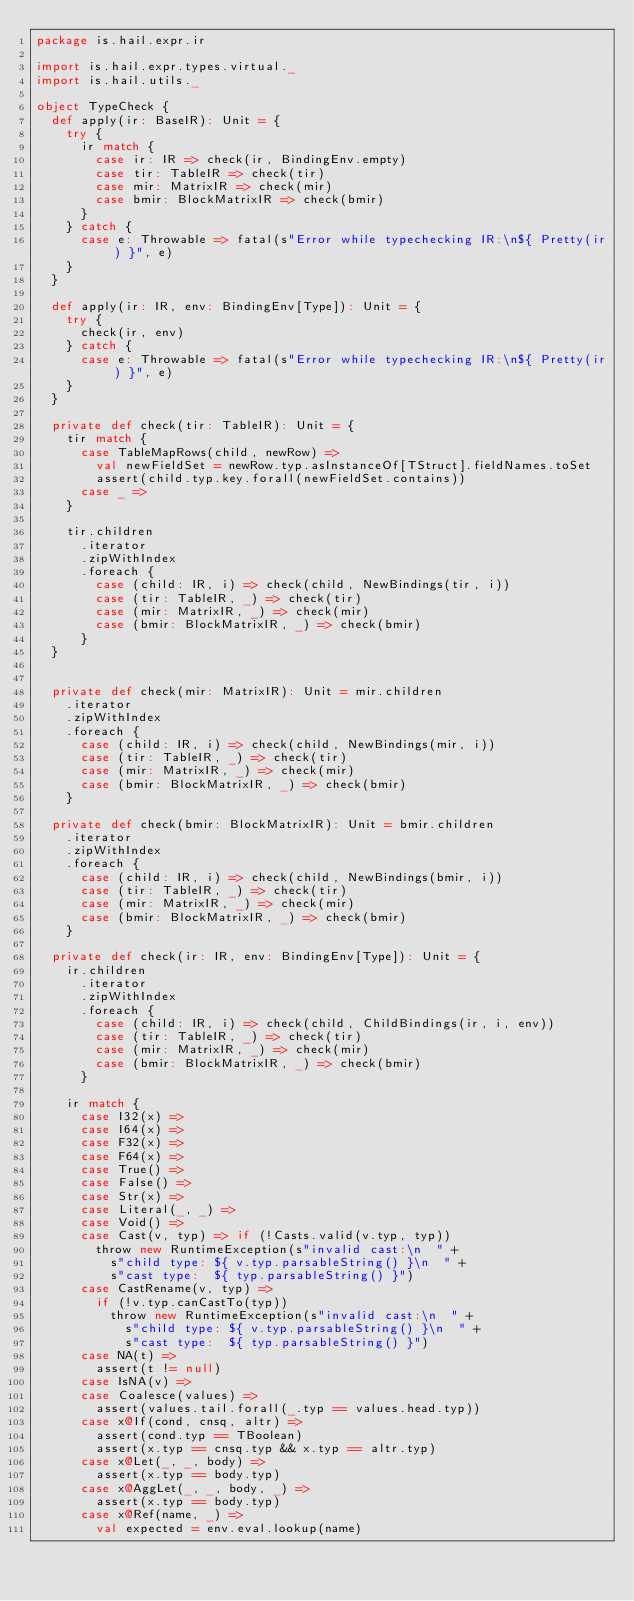<code> <loc_0><loc_0><loc_500><loc_500><_Scala_>package is.hail.expr.ir

import is.hail.expr.types.virtual._
import is.hail.utils._

object TypeCheck {
  def apply(ir: BaseIR): Unit = {
    try {
      ir match {
        case ir: IR => check(ir, BindingEnv.empty)
        case tir: TableIR => check(tir)
        case mir: MatrixIR => check(mir)
        case bmir: BlockMatrixIR => check(bmir)
      }
    } catch {
      case e: Throwable => fatal(s"Error while typechecking IR:\n${ Pretty(ir) }", e)
    }
  }

  def apply(ir: IR, env: BindingEnv[Type]): Unit = {
    try {
      check(ir, env)
    } catch {
      case e: Throwable => fatal(s"Error while typechecking IR:\n${ Pretty(ir) }", e)
    }
  }

  private def check(tir: TableIR): Unit = {
    tir match {
      case TableMapRows(child, newRow) =>
        val newFieldSet = newRow.typ.asInstanceOf[TStruct].fieldNames.toSet
        assert(child.typ.key.forall(newFieldSet.contains))
      case _ =>
    }

    tir.children
      .iterator
      .zipWithIndex
      .foreach {
        case (child: IR, i) => check(child, NewBindings(tir, i))
        case (tir: TableIR, _) => check(tir)
        case (mir: MatrixIR, _) => check(mir)
        case (bmir: BlockMatrixIR, _) => check(bmir)
      }
  }


  private def check(mir: MatrixIR): Unit = mir.children
    .iterator
    .zipWithIndex
    .foreach {
      case (child: IR, i) => check(child, NewBindings(mir, i))
      case (tir: TableIR, _) => check(tir)
      case (mir: MatrixIR, _) => check(mir)
      case (bmir: BlockMatrixIR, _) => check(bmir)
    }

  private def check(bmir: BlockMatrixIR): Unit = bmir.children
    .iterator
    .zipWithIndex
    .foreach {
      case (child: IR, i) => check(child, NewBindings(bmir, i))
      case (tir: TableIR, _) => check(tir)
      case (mir: MatrixIR, _) => check(mir)
      case (bmir: BlockMatrixIR, _) => check(bmir)
    }

  private def check(ir: IR, env: BindingEnv[Type]): Unit = {
    ir.children
      .iterator
      .zipWithIndex
      .foreach {
        case (child: IR, i) => check(child, ChildBindings(ir, i, env))
        case (tir: TableIR, _) => check(tir)
        case (mir: MatrixIR, _) => check(mir)
        case (bmir: BlockMatrixIR, _) => check(bmir)
      }

    ir match {
      case I32(x) =>
      case I64(x) =>
      case F32(x) =>
      case F64(x) =>
      case True() =>
      case False() =>
      case Str(x) =>
      case Literal(_, _) =>
      case Void() =>
      case Cast(v, typ) => if (!Casts.valid(v.typ, typ))
        throw new RuntimeException(s"invalid cast:\n  " +
          s"child type: ${ v.typ.parsableString() }\n  " +
          s"cast type:  ${ typ.parsableString() }")
      case CastRename(v, typ) =>
        if (!v.typ.canCastTo(typ))
          throw new RuntimeException(s"invalid cast:\n  " +
            s"child type: ${ v.typ.parsableString() }\n  " +
            s"cast type:  ${ typ.parsableString() }")
      case NA(t) =>
        assert(t != null)
      case IsNA(v) =>
      case Coalesce(values) =>
        assert(values.tail.forall(_.typ == values.head.typ))
      case x@If(cond, cnsq, altr) =>
        assert(cond.typ == TBoolean)
        assert(x.typ == cnsq.typ && x.typ == altr.typ)
      case x@Let(_, _, body) =>
        assert(x.typ == body.typ)
      case x@AggLet(_, _, body, _) =>
        assert(x.typ == body.typ)
      case x@Ref(name, _) =>
        val expected = env.eval.lookup(name)</code> 